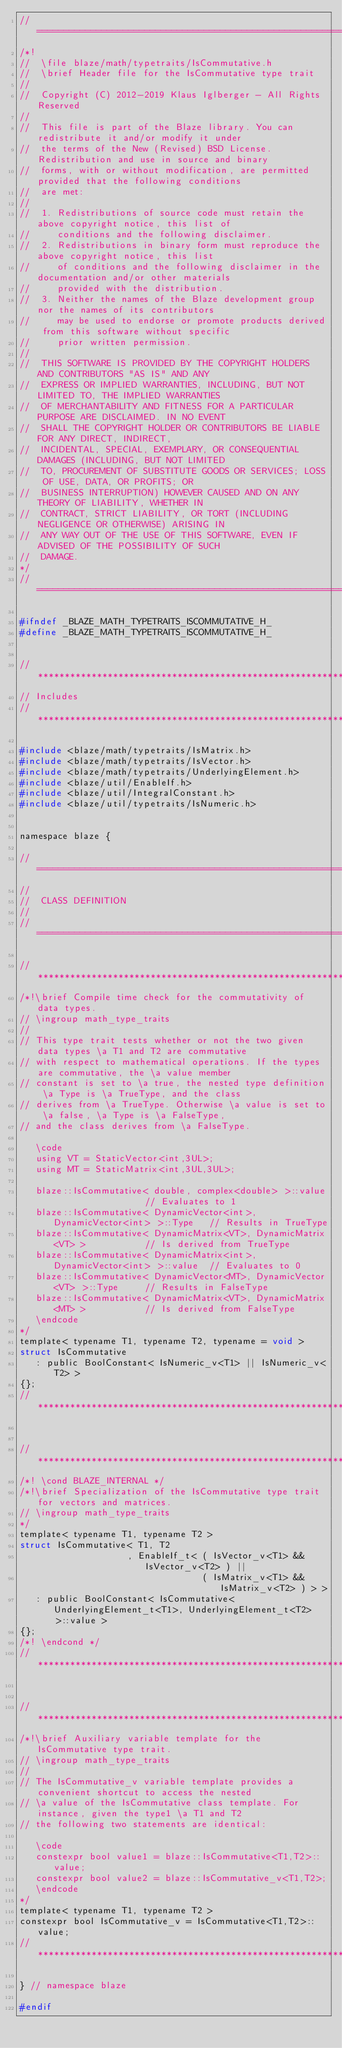Convert code to text. <code><loc_0><loc_0><loc_500><loc_500><_C_>//=================================================================================================
/*!
//  \file blaze/math/typetraits/IsCommutative.h
//  \brief Header file for the IsCommutative type trait
//
//  Copyright (C) 2012-2019 Klaus Iglberger - All Rights Reserved
//
//  This file is part of the Blaze library. You can redistribute it and/or modify it under
//  the terms of the New (Revised) BSD License. Redistribution and use in source and binary
//  forms, with or without modification, are permitted provided that the following conditions
//  are met:
//
//  1. Redistributions of source code must retain the above copyright notice, this list of
//     conditions and the following disclaimer.
//  2. Redistributions in binary form must reproduce the above copyright notice, this list
//     of conditions and the following disclaimer in the documentation and/or other materials
//     provided with the distribution.
//  3. Neither the names of the Blaze development group nor the names of its contributors
//     may be used to endorse or promote products derived from this software without specific
//     prior written permission.
//
//  THIS SOFTWARE IS PROVIDED BY THE COPYRIGHT HOLDERS AND CONTRIBUTORS "AS IS" AND ANY
//  EXPRESS OR IMPLIED WARRANTIES, INCLUDING, BUT NOT LIMITED TO, THE IMPLIED WARRANTIES
//  OF MERCHANTABILITY AND FITNESS FOR A PARTICULAR PURPOSE ARE DISCLAIMED. IN NO EVENT
//  SHALL THE COPYRIGHT HOLDER OR CONTRIBUTORS BE LIABLE FOR ANY DIRECT, INDIRECT,
//  INCIDENTAL, SPECIAL, EXEMPLARY, OR CONSEQUENTIAL DAMAGES (INCLUDING, BUT NOT LIMITED
//  TO, PROCUREMENT OF SUBSTITUTE GOODS OR SERVICES; LOSS OF USE, DATA, OR PROFITS; OR
//  BUSINESS INTERRUPTION) HOWEVER CAUSED AND ON ANY THEORY OF LIABILITY, WHETHER IN
//  CONTRACT, STRICT LIABILITY, OR TORT (INCLUDING NEGLIGENCE OR OTHERWISE) ARISING IN
//  ANY WAY OUT OF THE USE OF THIS SOFTWARE, EVEN IF ADVISED OF THE POSSIBILITY OF SUCH
//  DAMAGE.
*/
//=================================================================================================

#ifndef _BLAZE_MATH_TYPETRAITS_ISCOMMUTATIVE_H_
#define _BLAZE_MATH_TYPETRAITS_ISCOMMUTATIVE_H_


//*************************************************************************************************
// Includes
//*************************************************************************************************

#include <blaze/math/typetraits/IsMatrix.h>
#include <blaze/math/typetraits/IsVector.h>
#include <blaze/math/typetraits/UnderlyingElement.h>
#include <blaze/util/EnableIf.h>
#include <blaze/util/IntegralConstant.h>
#include <blaze/util/typetraits/IsNumeric.h>


namespace blaze {

//=================================================================================================
//
//  CLASS DEFINITION
//
//=================================================================================================

//*************************************************************************************************
/*!\brief Compile time check for the commutativity of data types.
// \ingroup math_type_traits
//
// This type trait tests whether or not the two given data types \a T1 and T2 are commutative
// with respect to mathematical operations. If the types are commutative, the \a value member
// constant is set to \a true, the nested type definition \a Type is \a TrueType, and the class
// derives from \a TrueType. Otherwise \a value is set to \a false, \a Type is \a FalseType,
// and the class derives from \a FalseType.

   \code
   using VT = StaticVector<int,3UL>;
   using MT = StaticMatrix<int,3UL,3UL>;

   blaze::IsCommutative< double, complex<double> >::value                 // Evaluates to 1
   blaze::IsCommutative< DynamicVector<int>, DynamicVector<int> >::Type   // Results in TrueType
   blaze::IsCommutative< DynamicMatrix<VT>, DynamicMatrix<VT> >           // Is derived from TrueType
   blaze::IsCommutative< DynamicMatrix<int>, DynamicVector<int> >::value  // Evaluates to 0
   blaze::IsCommutative< DynamicVector<MT>, DynamicVector<VT> >::Type     // Results in FalseType
   blaze::IsCommutative< DynamicMatrix<VT>, DynamicMatrix<MT> >           // Is derived from FalseType
   \endcode
*/
template< typename T1, typename T2, typename = void >
struct IsCommutative
   : public BoolConstant< IsNumeric_v<T1> || IsNumeric_v<T2> >
{};
//*************************************************************************************************


//*************************************************************************************************
/*! \cond BLAZE_INTERNAL */
/*!\brief Specialization of the IsCommutative type trait for vectors and matrices.
// \ingroup math_type_traits
*/
template< typename T1, typename T2 >
struct IsCommutative< T1, T2
                    , EnableIf_t< ( IsVector_v<T1> && IsVector_v<T2> ) ||
                                  ( IsMatrix_v<T1> && IsMatrix_v<T2> ) > >
   : public BoolConstant< IsCommutative< UnderlyingElement_t<T1>, UnderlyingElement_t<T2> >::value >
{};
/*! \endcond */
//*************************************************************************************************


//*************************************************************************************************
/*!\brief Auxiliary variable template for the IsCommutative type trait.
// \ingroup math_type_traits
//
// The IsCommutative_v variable template provides a convenient shortcut to access the nested
// \a value of the IsCommutative class template. For instance, given the type1 \a T1 and T2
// the following two statements are identical:

   \code
   constexpr bool value1 = blaze::IsCommutative<T1,T2>::value;
   constexpr bool value2 = blaze::IsCommutative_v<T1,T2>;
   \endcode
*/
template< typename T1, typename T2 >
constexpr bool IsCommutative_v = IsCommutative<T1,T2>::value;
//*************************************************************************************************

} // namespace blaze

#endif
</code> 